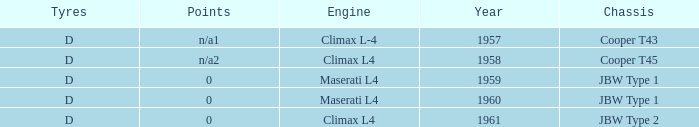What engine was for the vehicle with a cooper t43 chassis? Climax L-4. 